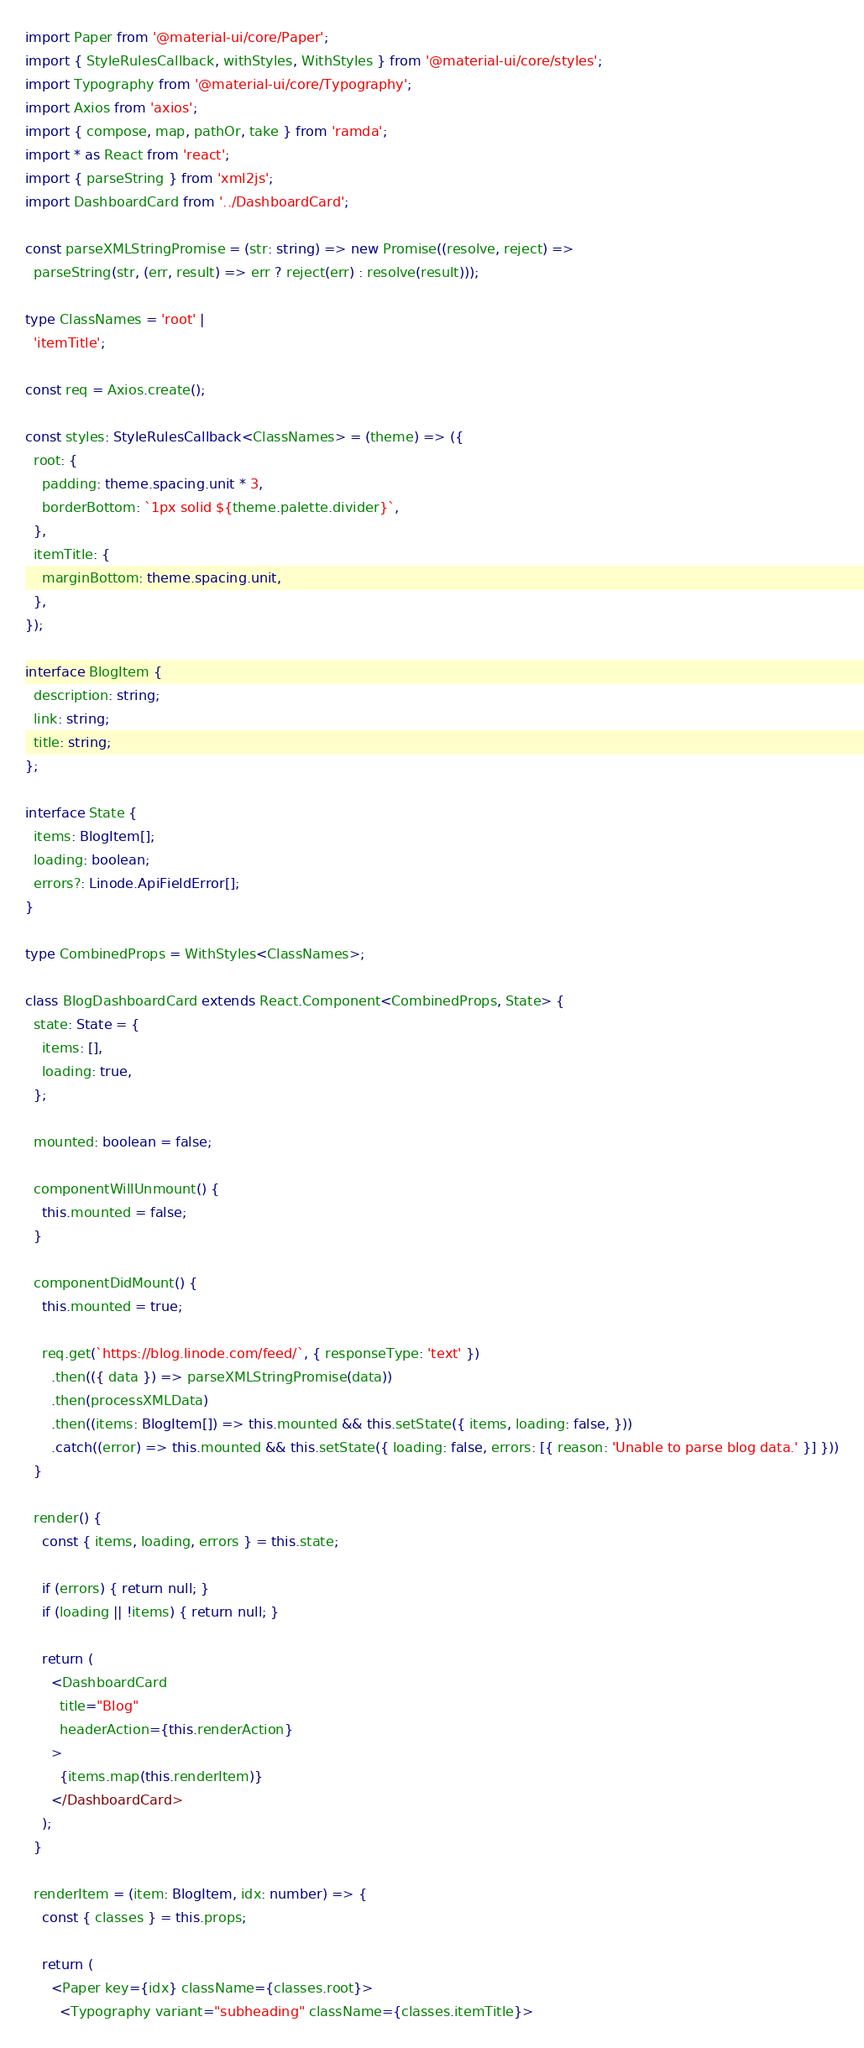Convert code to text. <code><loc_0><loc_0><loc_500><loc_500><_TypeScript_>import Paper from '@material-ui/core/Paper';
import { StyleRulesCallback, withStyles, WithStyles } from '@material-ui/core/styles';
import Typography from '@material-ui/core/Typography';
import Axios from 'axios';
import { compose, map, pathOr, take } from 'ramda';
import * as React from 'react';
import { parseString } from 'xml2js';
import DashboardCard from '../DashboardCard';

const parseXMLStringPromise = (str: string) => new Promise((resolve, reject) =>
  parseString(str, (err, result) => err ? reject(err) : resolve(result)));

type ClassNames = 'root' |
  'itemTitle';

const req = Axios.create();

const styles: StyleRulesCallback<ClassNames> = (theme) => ({
  root: {
    padding: theme.spacing.unit * 3,
    borderBottom: `1px solid ${theme.palette.divider}`,
  },
  itemTitle: {
    marginBottom: theme.spacing.unit,
  },
});

interface BlogItem {
  description: string;
  link: string;
  title: string;
};

interface State {
  items: BlogItem[];
  loading: boolean;
  errors?: Linode.ApiFieldError[];
}

type CombinedProps = WithStyles<ClassNames>;

class BlogDashboardCard extends React.Component<CombinedProps, State> {
  state: State = {
    items: [],
    loading: true,
  };

  mounted: boolean = false;

  componentWillUnmount() {
    this.mounted = false;
  }

  componentDidMount() {
    this.mounted = true;

    req.get(`https://blog.linode.com/feed/`, { responseType: 'text' })
      .then(({ data }) => parseXMLStringPromise(data))
      .then(processXMLData)
      .then((items: BlogItem[]) => this.mounted && this.setState({ items, loading: false, }))
      .catch((error) => this.mounted && this.setState({ loading: false, errors: [{ reason: 'Unable to parse blog data.' }] }))
  }

  render() {
    const { items, loading, errors } = this.state;

    if (errors) { return null; }
    if (loading || !items) { return null; }

    return (
      <DashboardCard
        title="Blog"
        headerAction={this.renderAction}
      >
        {items.map(this.renderItem)}
      </DashboardCard>
    );
  }

  renderItem = (item: BlogItem, idx: number) => {
    const { classes } = this.props;

    return (
      <Paper key={idx} className={classes.root}>
        <Typography variant="subheading" className={classes.itemTitle}></code> 